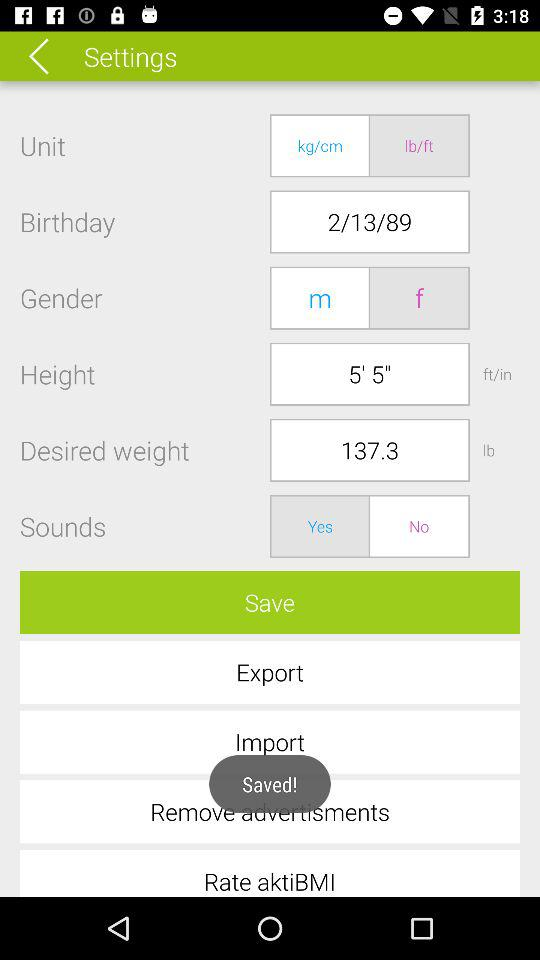What is the option for sounds? The options are "Yes" and "No". 